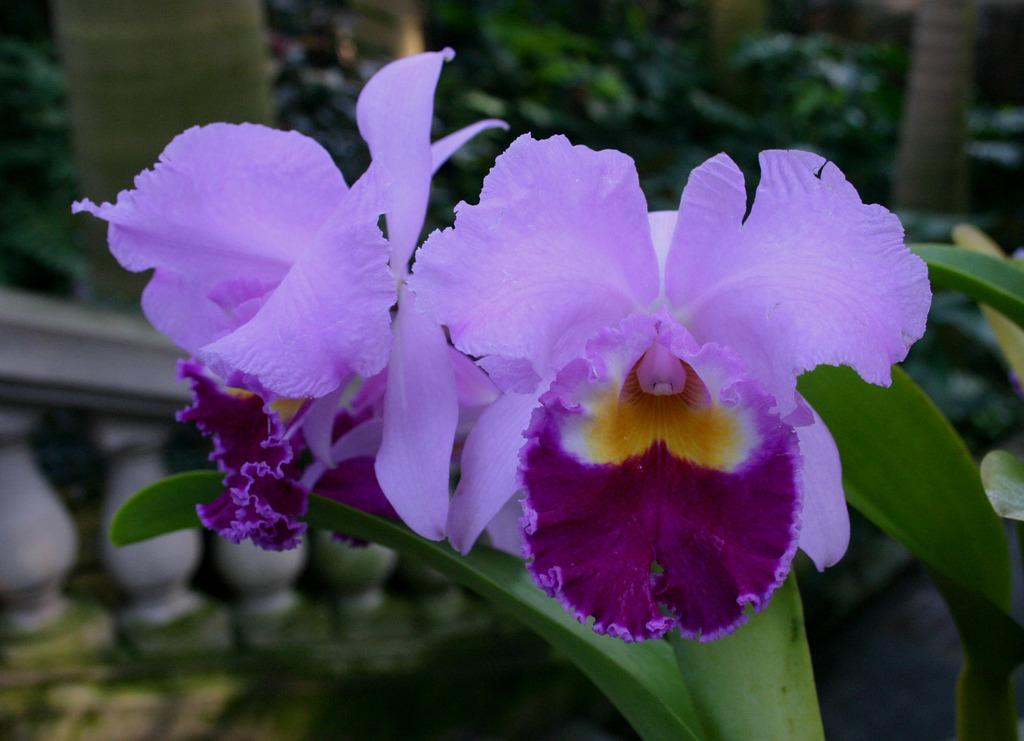What type of plants can be seen in the image? There are flowers in the image. What is visible in the background of the image? There is a fence and trees in the background of the image. How many oranges are hanging from the trees in the image? There are no oranges present in the image; it features flowers and trees without any fruit. What type of wall can be seen in the image? There is no wall present in the image; it features a fence in the background. 